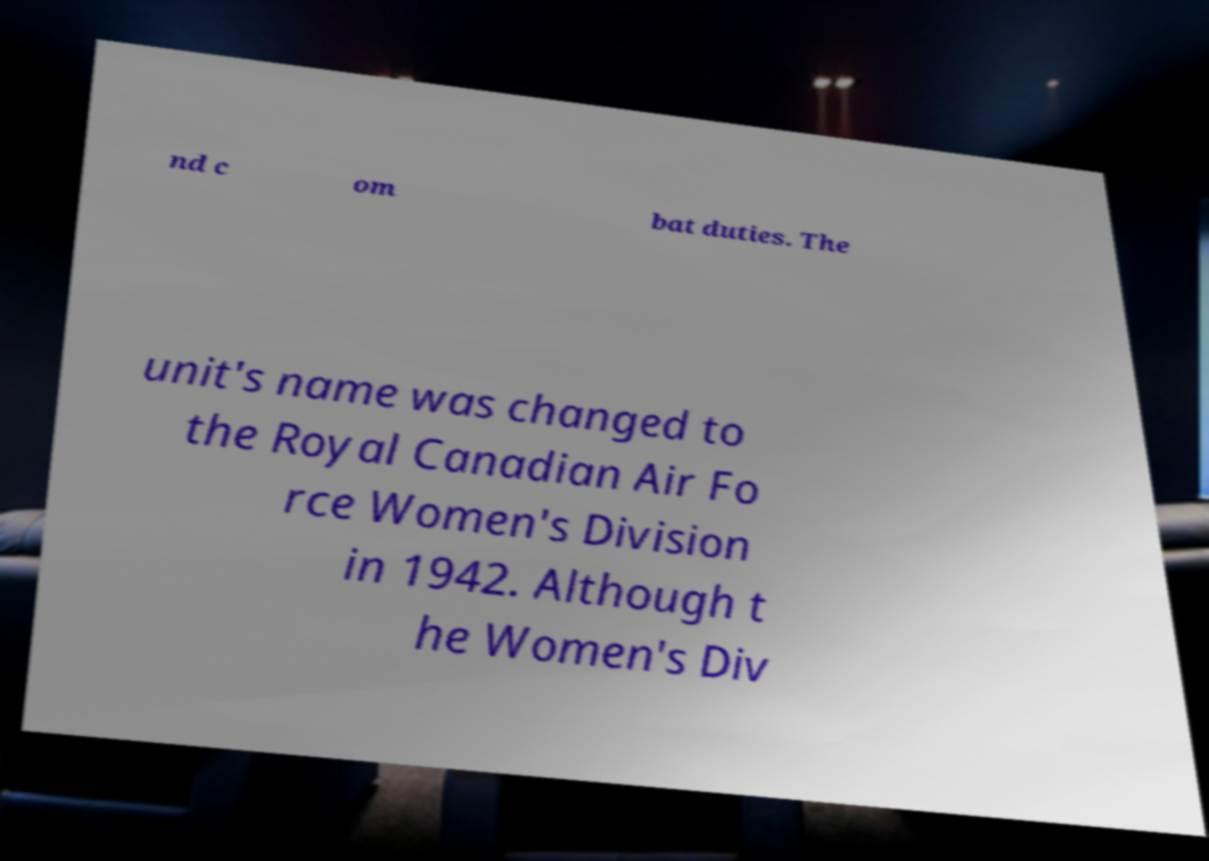I need the written content from this picture converted into text. Can you do that? nd c om bat duties. The unit's name was changed to the Royal Canadian Air Fo rce Women's Division in 1942. Although t he Women's Div 